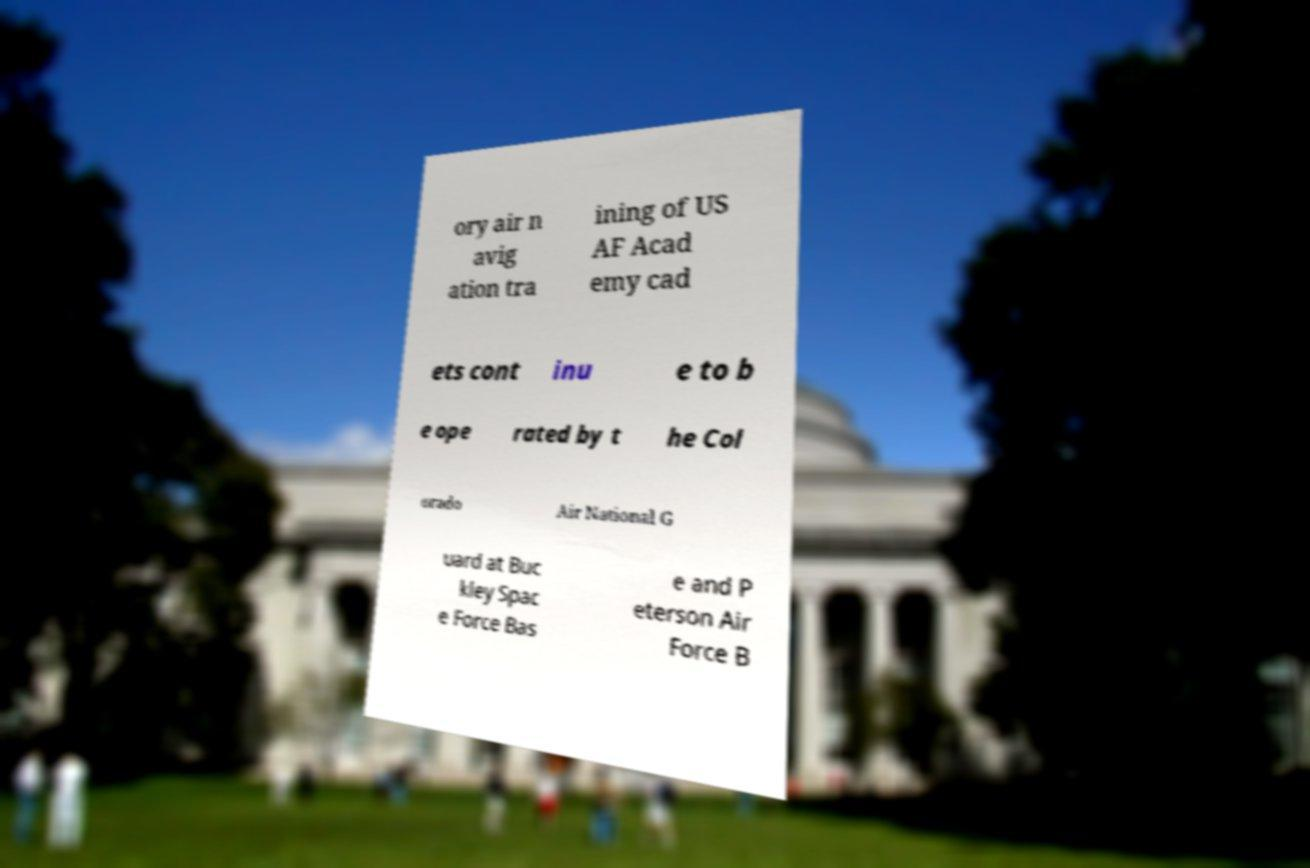Can you accurately transcribe the text from the provided image for me? ory air n avig ation tra ining of US AF Acad emy cad ets cont inu e to b e ope rated by t he Col orado Air National G uard at Buc kley Spac e Force Bas e and P eterson Air Force B 